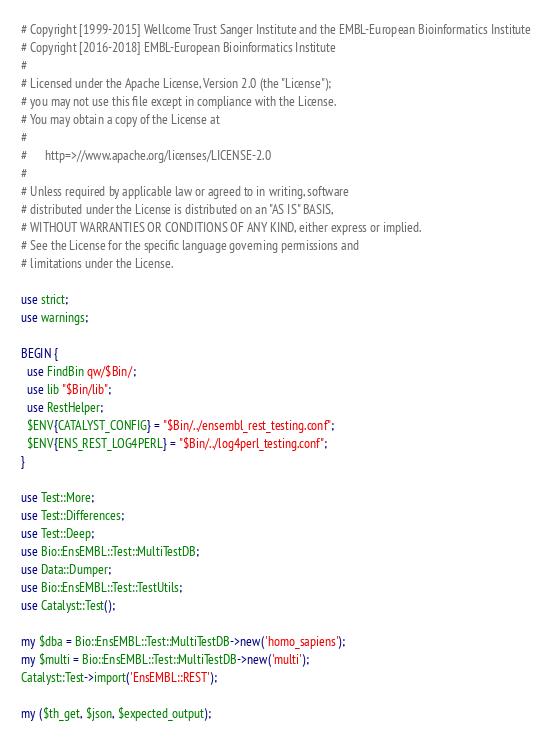<code> <loc_0><loc_0><loc_500><loc_500><_Perl_># Copyright [1999-2015] Wellcome Trust Sanger Institute and the EMBL-European Bioinformatics Institute 
# Copyright [2016-2018] EMBL-European Bioinformatics Institute
#
# Licensed under the Apache License, Version 2.0 (the "License");
# you may not use this file except in compliance with the License.
# You may obtain a copy of the License at
#
#      http=>//www.apache.org/licenses/LICENSE-2.0
#
# Unless required by applicable law or agreed to in writing, software
# distributed under the License is distributed on an "AS IS" BASIS,
# WITHOUT WARRANTIES OR CONDITIONS OF ANY KIND, either express or implied.
# See the License for the specific language governing permissions and
# limitations under the License.

use strict;
use warnings;

BEGIN {
  use FindBin qw/$Bin/;
  use lib "$Bin/lib";
  use RestHelper;
  $ENV{CATALYST_CONFIG} = "$Bin/../ensembl_rest_testing.conf";
  $ENV{ENS_REST_LOG4PERL} = "$Bin/../log4perl_testing.conf";
}

use Test::More;
use Test::Differences;
use Test::Deep;
use Bio::EnsEMBL::Test::MultiTestDB;
use Data::Dumper;
use Bio::EnsEMBL::Test::TestUtils;
use Catalyst::Test();

my $dba = Bio::EnsEMBL::Test::MultiTestDB->new('homo_sapiens');
my $multi = Bio::EnsEMBL::Test::MultiTestDB->new('multi');
Catalyst::Test->import('EnsEMBL::REST');

my ($th_get, $json, $expected_output);
</code> 